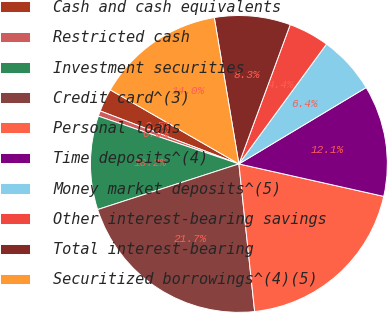<chart> <loc_0><loc_0><loc_500><loc_500><pie_chart><fcel>Cash and cash equivalents<fcel>Restricted cash<fcel>Investment securities<fcel>Credit card^(3)<fcel>Personal loans<fcel>Time deposits^(4)<fcel>Money market deposits^(5)<fcel>Other interest-bearing savings<fcel>Total interest-bearing<fcel>Securitized borrowings^(4)(5)<nl><fcel>2.51%<fcel>0.59%<fcel>10.19%<fcel>21.72%<fcel>19.8%<fcel>12.11%<fcel>6.35%<fcel>4.43%<fcel>8.27%<fcel>14.03%<nl></chart> 